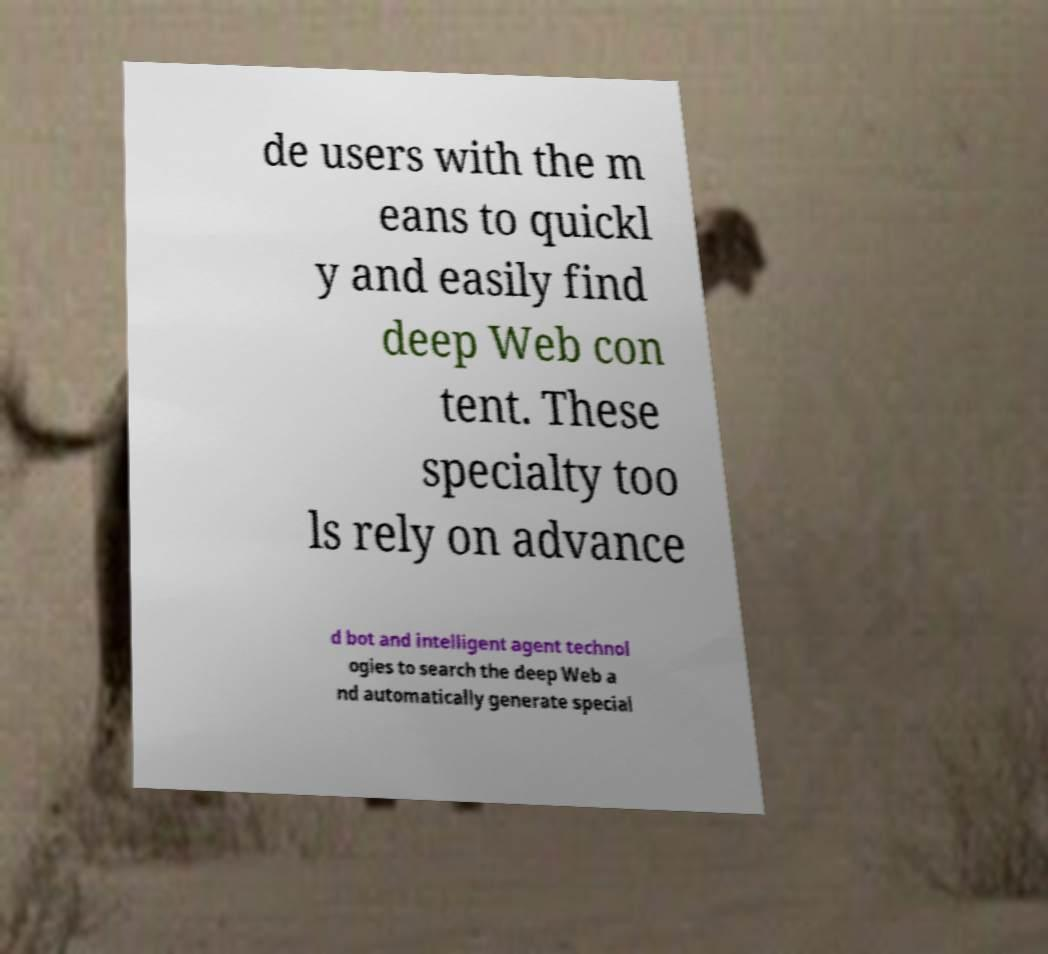Could you assist in decoding the text presented in this image and type it out clearly? de users with the m eans to quickl y and easily find deep Web con tent. These specialty too ls rely on advance d bot and intelligent agent technol ogies to search the deep Web a nd automatically generate special 